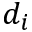<formula> <loc_0><loc_0><loc_500><loc_500>d _ { i }</formula> 